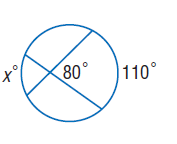Question: Find x. Assume that segments that appear to be tangent are tangent.
Choices:
A. 50
B. 75
C. 80
D. 110
Answer with the letter. Answer: A 